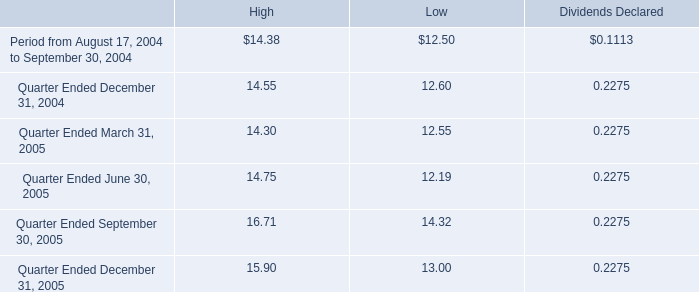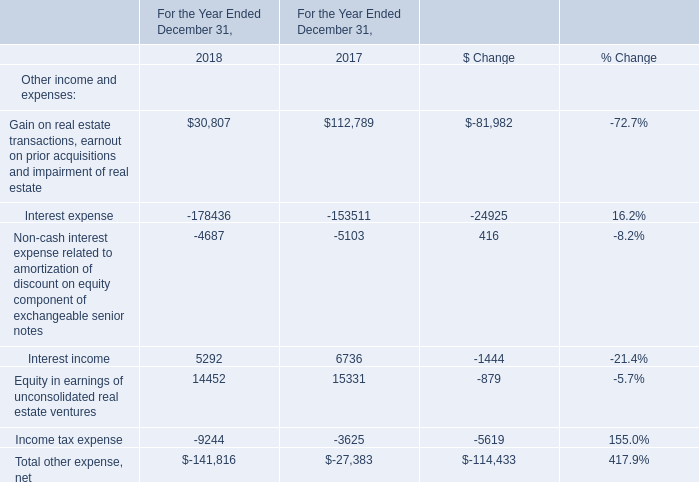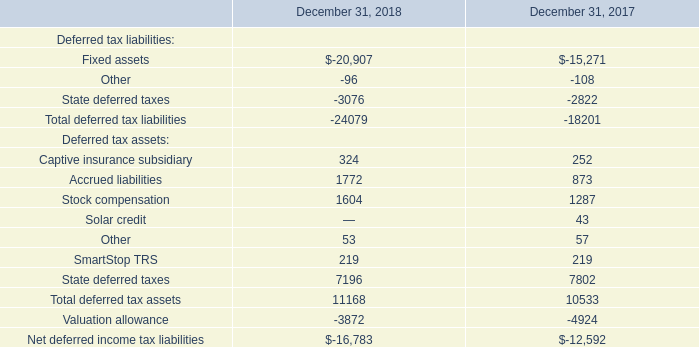What's the total amount of the Interest income for Other income and expenses in the years where Captive insurance subsidiary for Deferred tax assets is greater than 0? 
Computations: (5292 + 6736)
Answer: 12028.0. 